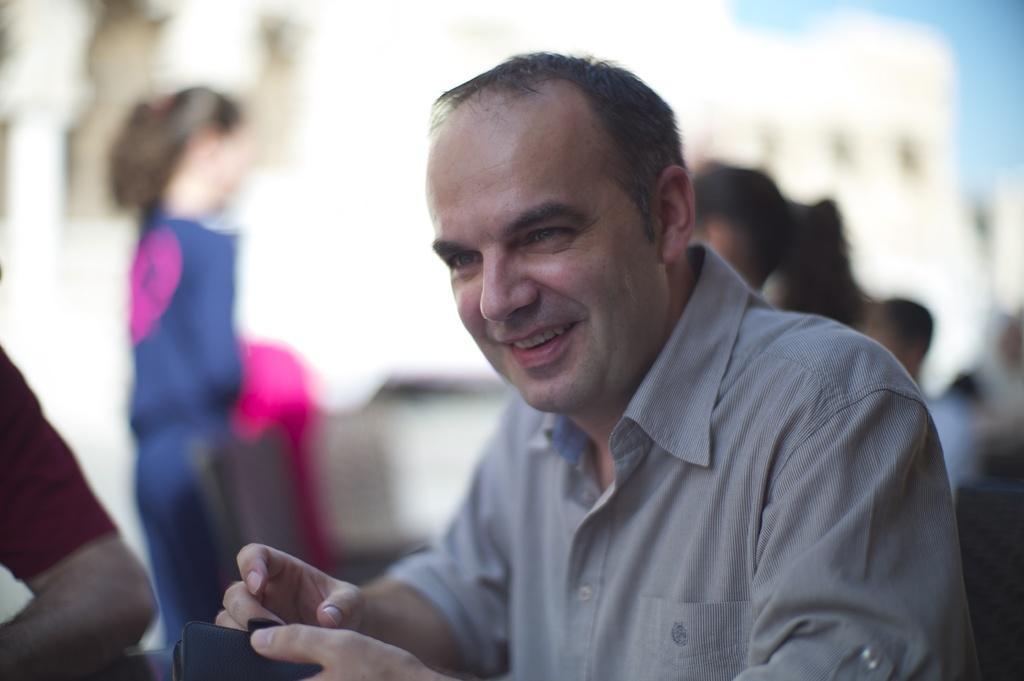How would you summarize this image in a sentence or two? The man in front of the picture wearing the grey shirt is sitting on the chair and he is holding a black color wallet in his hands. He is smiling. Behind him, we see many people are standing. On the left side, we see a man in maroon T-shirt is sitting on the chair. In the background, we see a building in white color. This picture is blurred in the background. 